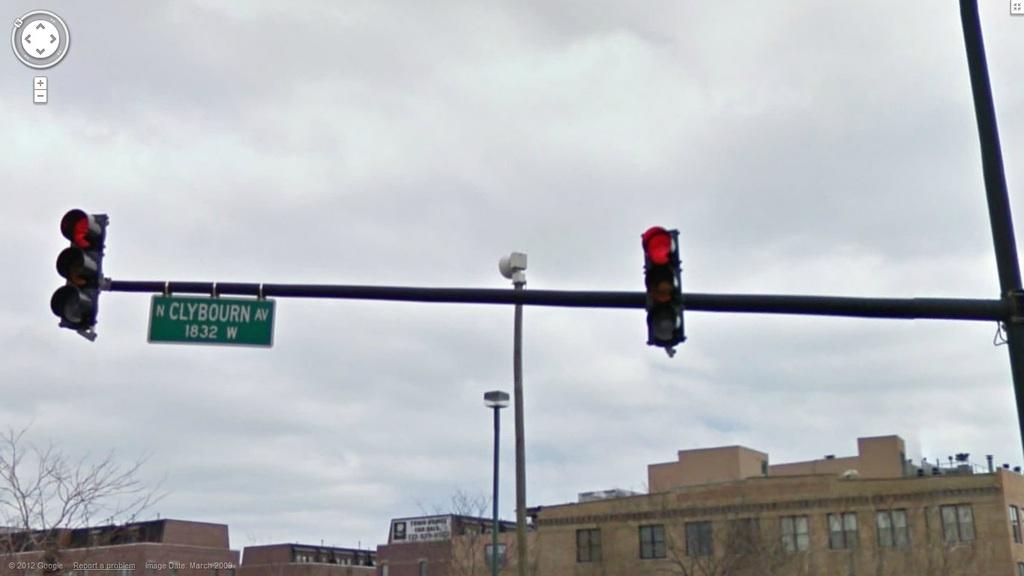What is the cardinal direction for clybourn ave?
Your answer should be compact. North. What is the name of this street?
Provide a succinct answer. Clybourn. 